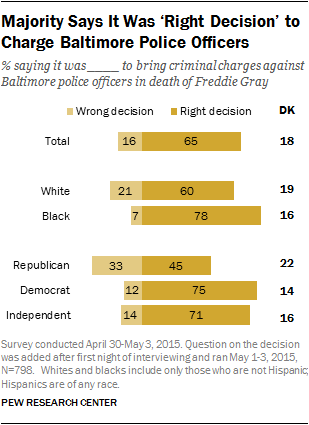Point out several critical features in this image. The value represented by the color yellow is... In the given text, 27% of white people who responded believe that the decision is right, while 47% of Republicans believe that the decision is wrong. 